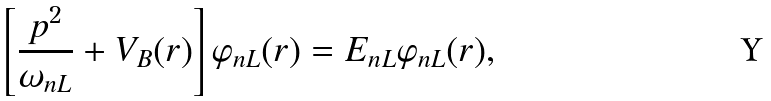Convert formula to latex. <formula><loc_0><loc_0><loc_500><loc_500>\left [ \frac { p ^ { 2 } } { \omega _ { n L } } + V _ { B } ( r ) \right ] \varphi _ { n L } ( r ) = E _ { n L } \varphi _ { n L } ( r ) ,</formula> 